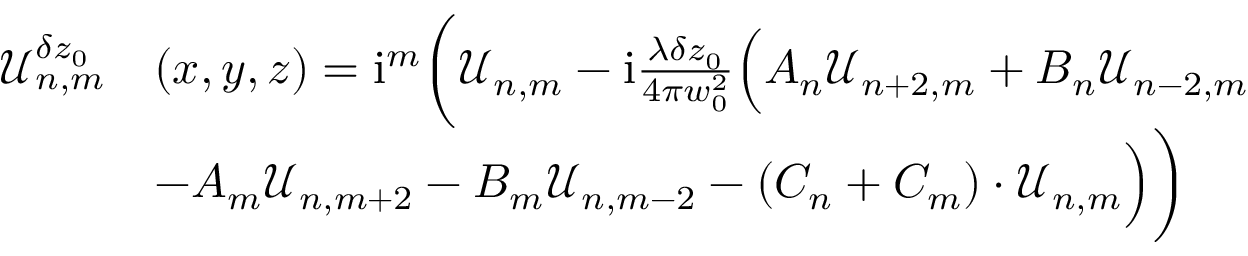<formula> <loc_0><loc_0><loc_500><loc_500>\begin{array} { r l } { \mathcal { U } _ { n , m } ^ { \delta z _ { 0 } } } & { ( x , y , z ) = i ^ { m } \left ( \mathcal { U } _ { n , m } - i \frac { \lambda \delta z _ { 0 } } { 4 \pi w _ { 0 } ^ { 2 } } \left ( A _ { n } \mathcal { U } _ { n + 2 , m } + B _ { n } \mathcal { U } _ { n - 2 , m } } \\ & { - A _ { m } \mathcal { U } _ { n , m + 2 } - B _ { m } \mathcal { U } _ { n , m - 2 } - ( C _ { n } + C _ { m } ) \cdot \mathcal { U } _ { n , m } \right ) \right ) } \end{array}</formula> 